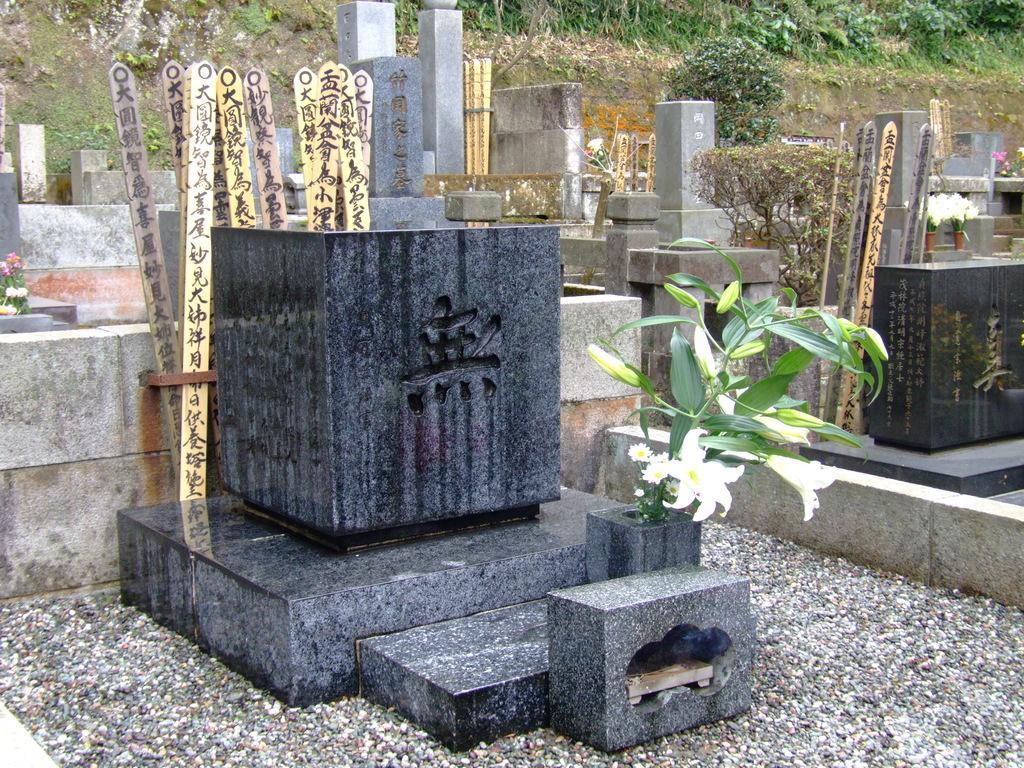Describe this image in one or two sentences. In the image we can see stones, flower plant, planter, wooden stick and a grass. 